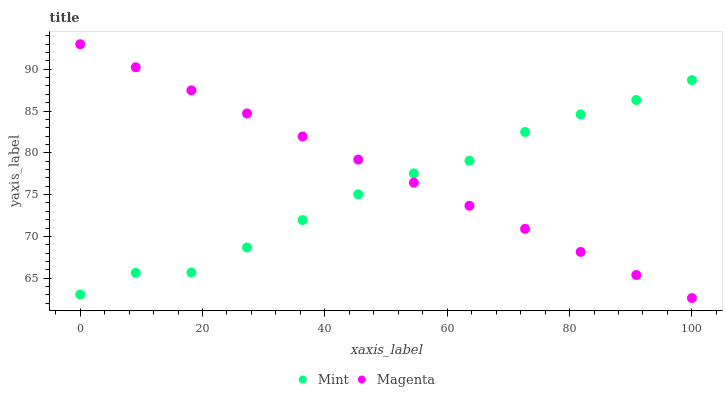Does Mint have the minimum area under the curve?
Answer yes or no. Yes. Does Magenta have the maximum area under the curve?
Answer yes or no. Yes. Does Mint have the maximum area under the curve?
Answer yes or no. No. Is Magenta the smoothest?
Answer yes or no. Yes. Is Mint the roughest?
Answer yes or no. Yes. Is Mint the smoothest?
Answer yes or no. No. Does Magenta have the lowest value?
Answer yes or no. Yes. Does Mint have the lowest value?
Answer yes or no. No. Does Magenta have the highest value?
Answer yes or no. Yes. Does Mint have the highest value?
Answer yes or no. No. Does Magenta intersect Mint?
Answer yes or no. Yes. Is Magenta less than Mint?
Answer yes or no. No. Is Magenta greater than Mint?
Answer yes or no. No. 